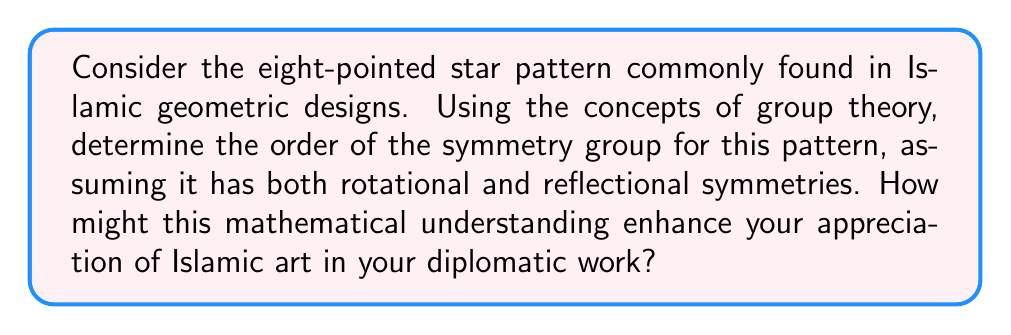Could you help me with this problem? To analyze the symmetry properties of the eight-pointed star pattern using abstract algebra, we'll follow these steps:

1. Identify the symmetries:
   - Rotational symmetries: The pattern has 8-fold rotational symmetry, meaning it can be rotated by multiples of 45° (360°/8) and remain unchanged.
   - Reflectional symmetries: The pattern has 8 lines of reflection (4 through the points and 4 through the midpoints between adjacent points).

2. Determine the symmetry group:
   The symmetry group of this pattern is known as the dihedral group $D_8$.

3. Calculate the order of the group:
   The order of a dihedral group $D_n$ is given by the formula:
   
   $$|D_n| = 2n$$

   Where $n$ is the number of rotational symmetries.

   In this case, $n = 8$, so:
   
   $$|D_8| = 2 \cdot 8 = 16$$

4. Understanding the group elements:
   - 8 rotations (including the identity rotation): $0°, 45°, 90°, 135°, 180°, 225°, 270°, 315°$
   - 8 reflections: 4 through the points and 4 through the midpoints

5. Relevance to Islamic art and diplomacy:
   Understanding the mathematical structure behind Islamic geometric patterns can provide:
   - A deeper appreciation of the precision and complexity in Islamic art
   - Insight into the cultural importance of symmetry and order in Islamic aesthetics
   - A bridge between mathematical concepts and artistic expression, potentially useful in cultural exchanges
   - A talking point for engaging with scholars, artists, or officials interested in the intersection of mathematics and Islamic art

This analysis demonstrates how abstract algebra can be applied to understand and quantify the symmetry in Islamic geometric patterns, providing a unique perspective that combines mathematics, art, and cultural studies.
Answer: The order of the symmetry group for the eight-pointed star pattern is 16. This group is the dihedral group $D_8$, which consists of 8 rotational symmetries and 8 reflectional symmetries. 